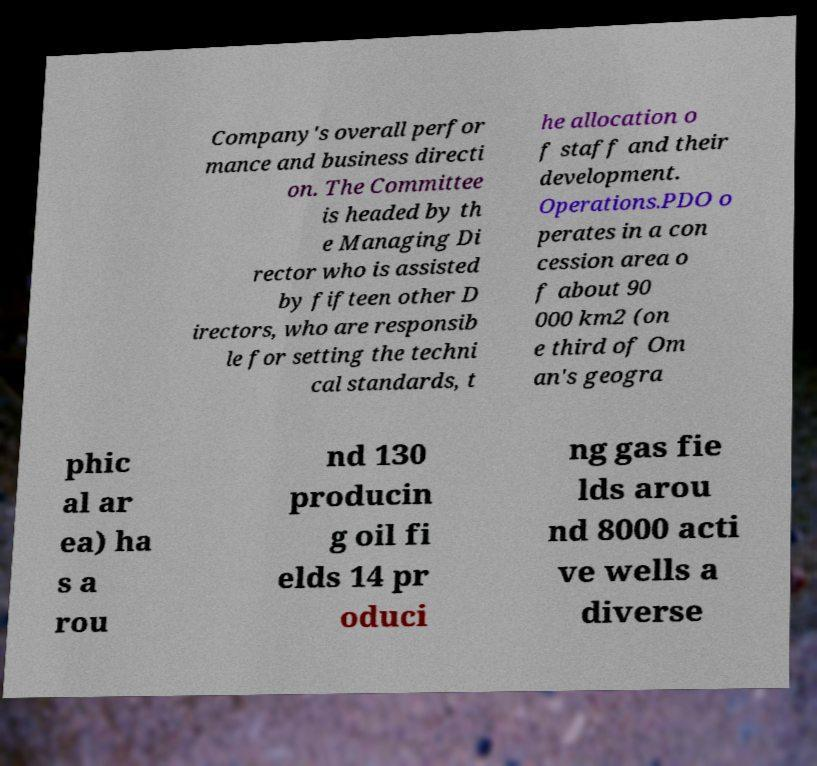For documentation purposes, I need the text within this image transcribed. Could you provide that? Company's overall perfor mance and business directi on. The Committee is headed by th e Managing Di rector who is assisted by fifteen other D irectors, who are responsib le for setting the techni cal standards, t he allocation o f staff and their development. Operations.PDO o perates in a con cession area o f about 90 000 km2 (on e third of Om an's geogra phic al ar ea) ha s a rou nd 130 producin g oil fi elds 14 pr oduci ng gas fie lds arou nd 8000 acti ve wells a diverse 